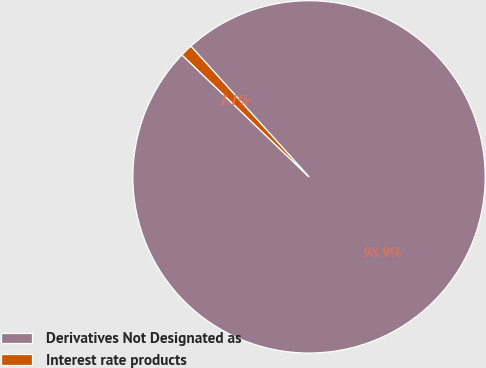Convert chart. <chart><loc_0><loc_0><loc_500><loc_500><pie_chart><fcel>Derivatives Not Designated as<fcel>Interest rate products<nl><fcel>98.87%<fcel>1.13%<nl></chart> 